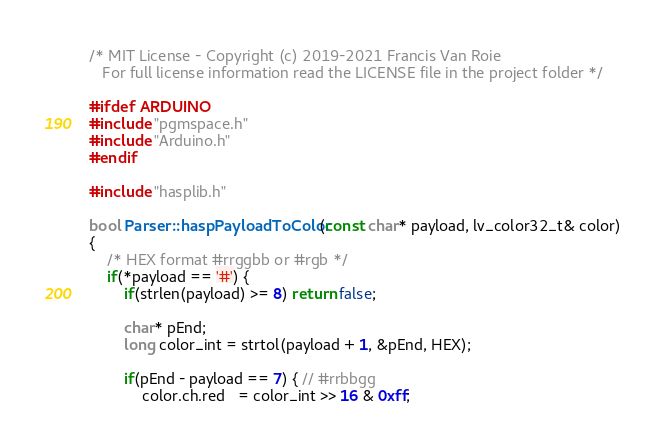Convert code to text. <code><loc_0><loc_0><loc_500><loc_500><_C++_>/* MIT License - Copyright (c) 2019-2021 Francis Van Roie
   For full license information read the LICENSE file in the project folder */

#ifdef ARDUINO
#include "pgmspace.h"
#include "Arduino.h"
#endif

#include "hasplib.h"

bool Parser::haspPayloadToColor(const char* payload, lv_color32_t& color)
{
    /* HEX format #rrggbb or #rgb */
    if(*payload == '#') {
        if(strlen(payload) >= 8) return false;

        char* pEnd;
        long color_int = strtol(payload + 1, &pEnd, HEX);

        if(pEnd - payload == 7) { // #rrbbgg
            color.ch.red   = color_int >> 16 & 0xff;</code> 